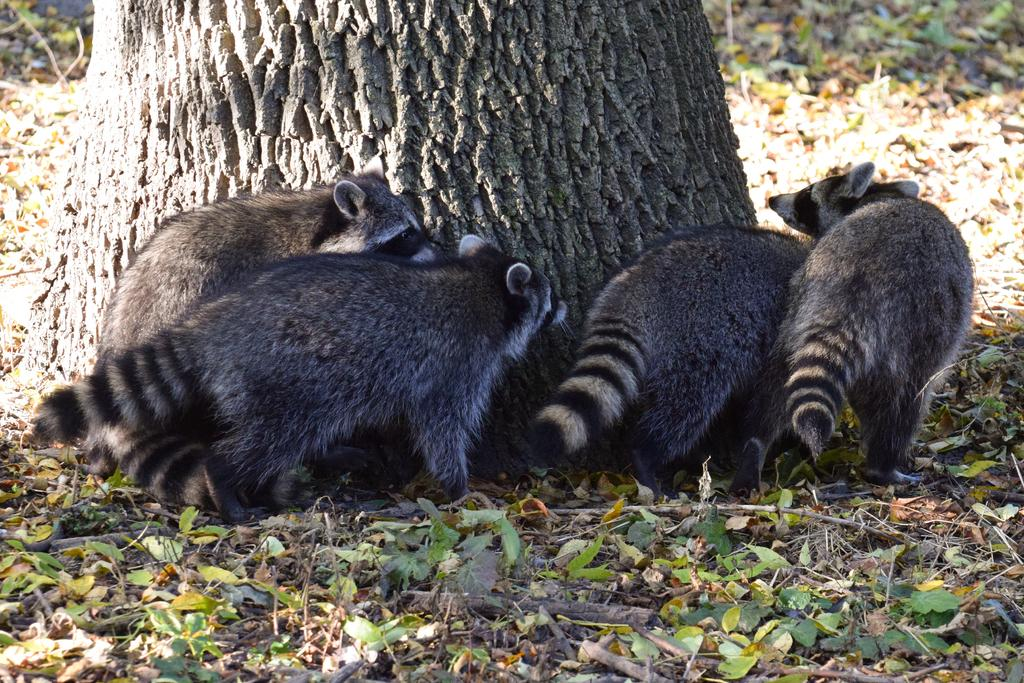What type of living organisms can be seen in the image? There are animals in the image. What are the animals doing in the image? The animals are walking on the ground. What can be seen at the bottom of the image? There are dry leaves at the bottom of the image. What is located in the front of the image? There is a tree in the front of the image. What type of environment is depicted in the image? The image appears to be taken in a forest. What type of doctor can be seen in the image? There is no doctor present in the image; it features animals walking in a forest setting. What emotion do the animals appear to be feeling in the image? The image does not convey any specific emotions of the animals, as they are simply walking on the ground. 